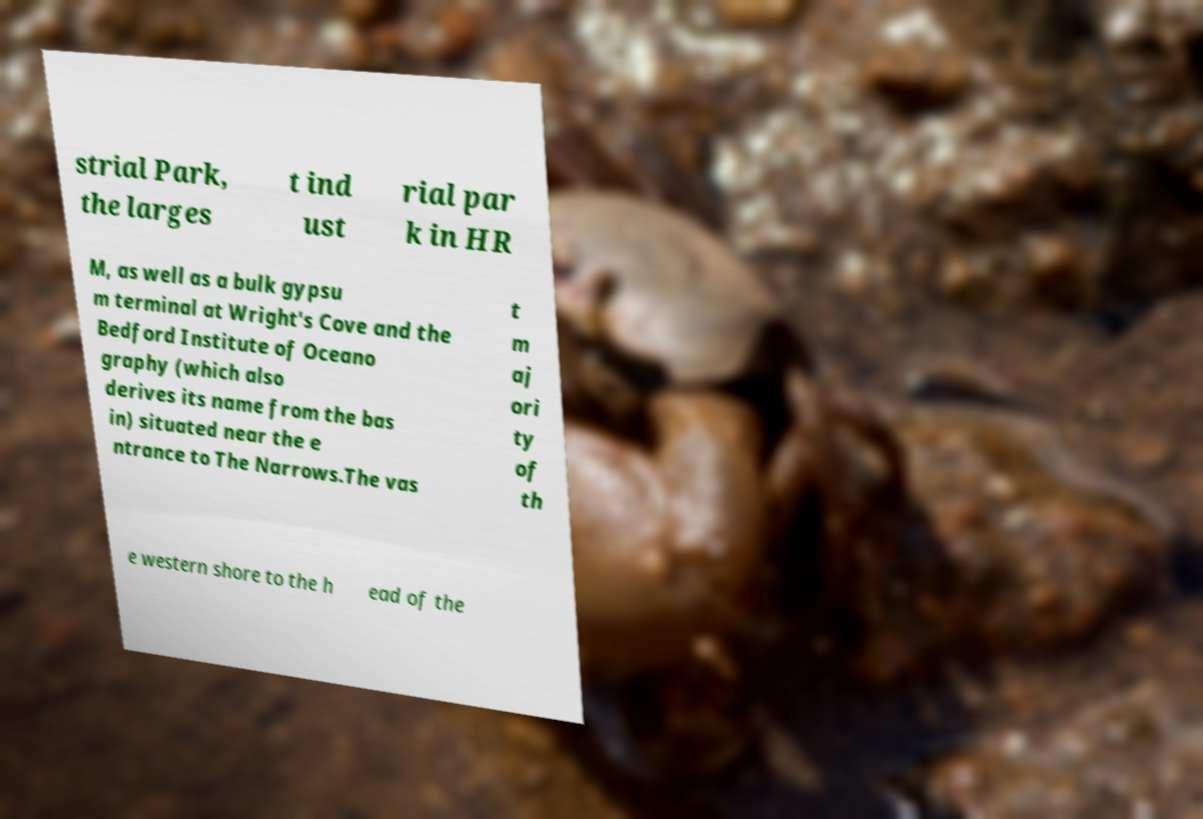For documentation purposes, I need the text within this image transcribed. Could you provide that? strial Park, the larges t ind ust rial par k in HR M, as well as a bulk gypsu m terminal at Wright's Cove and the Bedford Institute of Oceano graphy (which also derives its name from the bas in) situated near the e ntrance to The Narrows.The vas t m aj ori ty of th e western shore to the h ead of the 